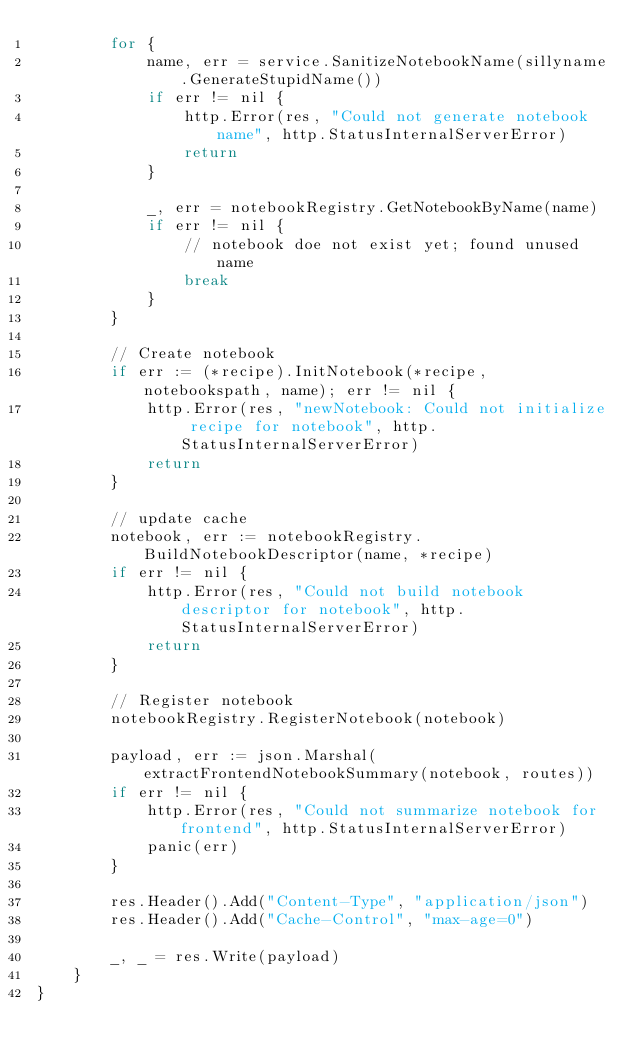Convert code to text. <code><loc_0><loc_0><loc_500><loc_500><_Go_>		for {
			name, err = service.SanitizeNotebookName(sillyname.GenerateStupidName())
			if err != nil {
				http.Error(res, "Could not generate notebook name", http.StatusInternalServerError)
				return
			}

			_, err = notebookRegistry.GetNotebookByName(name)
			if err != nil {
				// notebook doe not exist yet; found unused name
				break
			}
		}

		// Create notebook
		if err := (*recipe).InitNotebook(*recipe, notebookspath, name); err != nil {
			http.Error(res, "newNotebook: Could not initialize recipe for notebook", http.StatusInternalServerError)
			return
		}

		// update cache
		notebook, err := notebookRegistry.BuildNotebookDescriptor(name, *recipe)
		if err != nil {
			http.Error(res, "Could not build notebook descriptor for notebook", http.StatusInternalServerError)
			return
		}

		// Register notebook
		notebookRegistry.RegisterNotebook(notebook)

		payload, err := json.Marshal(extractFrontendNotebookSummary(notebook, routes))
		if err != nil {
			http.Error(res, "Could not summarize notebook for frontend", http.StatusInternalServerError)
			panic(err)
		}

		res.Header().Add("Content-Type", "application/json")
		res.Header().Add("Cache-Control", "max-age=0")

		_, _ = res.Write(payload)
	}
}
</code> 